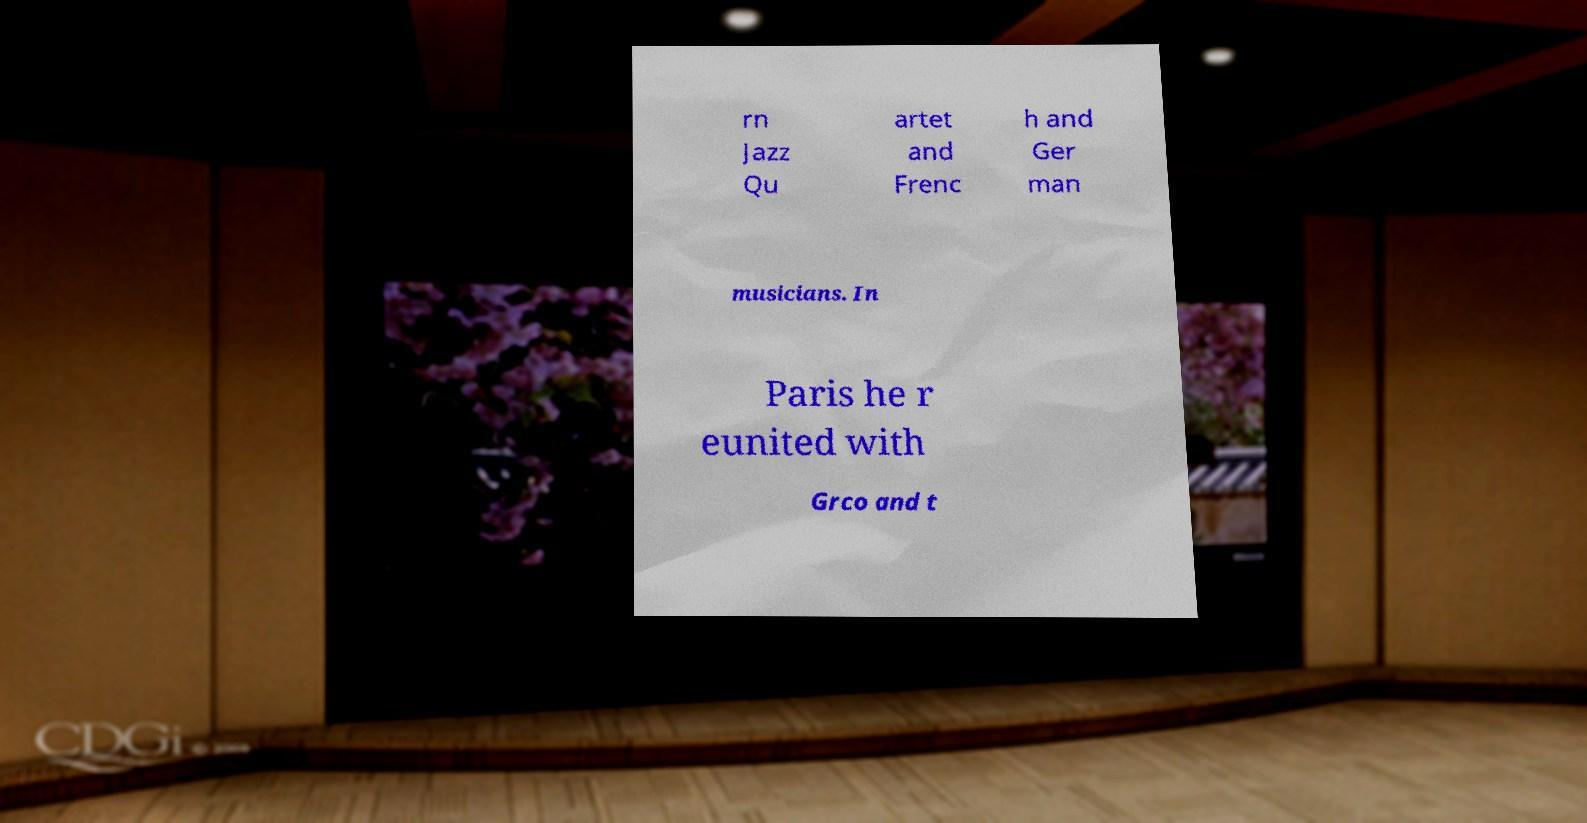Please read and relay the text visible in this image. What does it say? rn Jazz Qu artet and Frenc h and Ger man musicians. In Paris he r eunited with Grco and t 